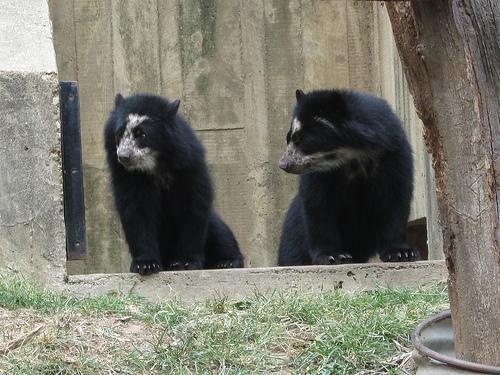How many animals are in this picture?
Give a very brief answer. 2. How many paws are visible?
Give a very brief answer. 4. How many noses are visible?
Give a very brief answer. 2. 